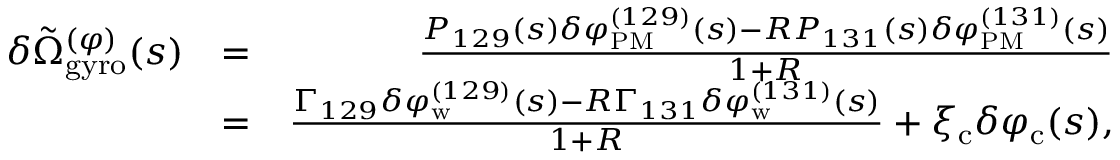Convert formula to latex. <formula><loc_0><loc_0><loc_500><loc_500>\begin{array} { r l r } { \delta \tilde { \Omega } _ { g y r o } ^ { ( \varphi ) } ( s ) } & { = } & { \frac { P _ { 1 2 9 } ( s ) \delta \varphi _ { P M } ^ { ( 1 2 9 ) } ( s ) - R P _ { 1 3 1 } ( s ) \delta \varphi _ { P M } ^ { ( 1 3 1 ) } ( s ) } { 1 + R } } \\ & { = } & { \frac { \Gamma _ { 1 2 9 } \delta \varphi _ { w } ^ { ( 1 2 9 ) } ( s ) - R \Gamma _ { 1 3 1 } \delta \varphi _ { w } ^ { ( 1 3 1 ) } ( s ) } { 1 + R } + \xi _ { c } \delta \varphi _ { c } ( s ) , } \end{array}</formula> 